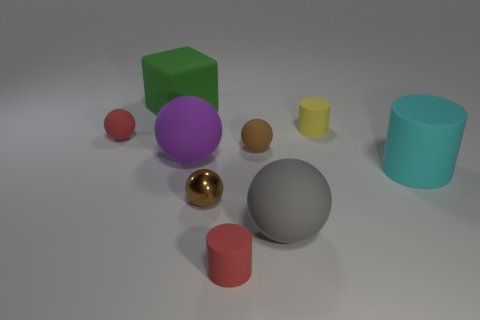Subtract all red balls. How many balls are left? 4 Subtract all yellow cylinders. How many brown balls are left? 2 Subtract all purple balls. How many balls are left? 4 Subtract 1 cylinders. How many cylinders are left? 2 Subtract all green spheres. Subtract all yellow cylinders. How many spheres are left? 5 Add 1 small brown shiny objects. How many objects exist? 10 Subtract all blocks. How many objects are left? 8 Add 8 cyan matte cylinders. How many cyan matte cylinders are left? 9 Add 7 rubber blocks. How many rubber blocks exist? 8 Subtract 0 cyan blocks. How many objects are left? 9 